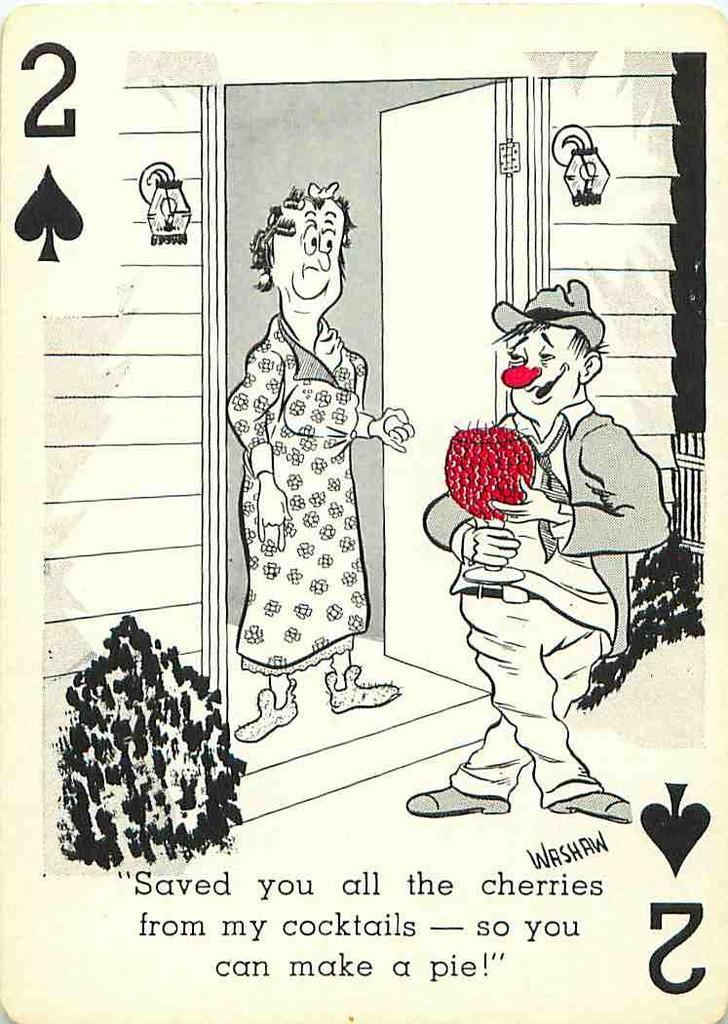Please provide a concise description of this image. In this picture there is a image of a person holding a bouquet in his hand and there is a woman in front of him standing and holding a door and there are few plants on either sides of them and there is something written below the image. 